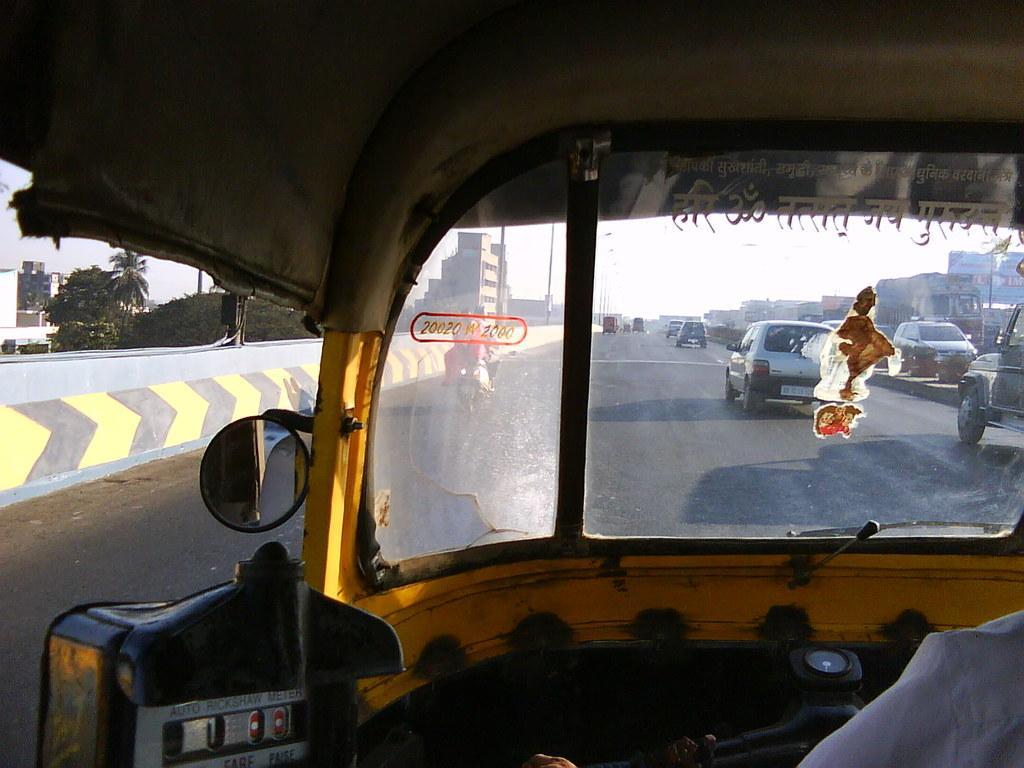Describe this image in one or two sentences. In this picture I can observe a road. This picture is taken from an auto rickshaw. I can observe some cars moving on the road. In the background there are trees, buildings and sky. 